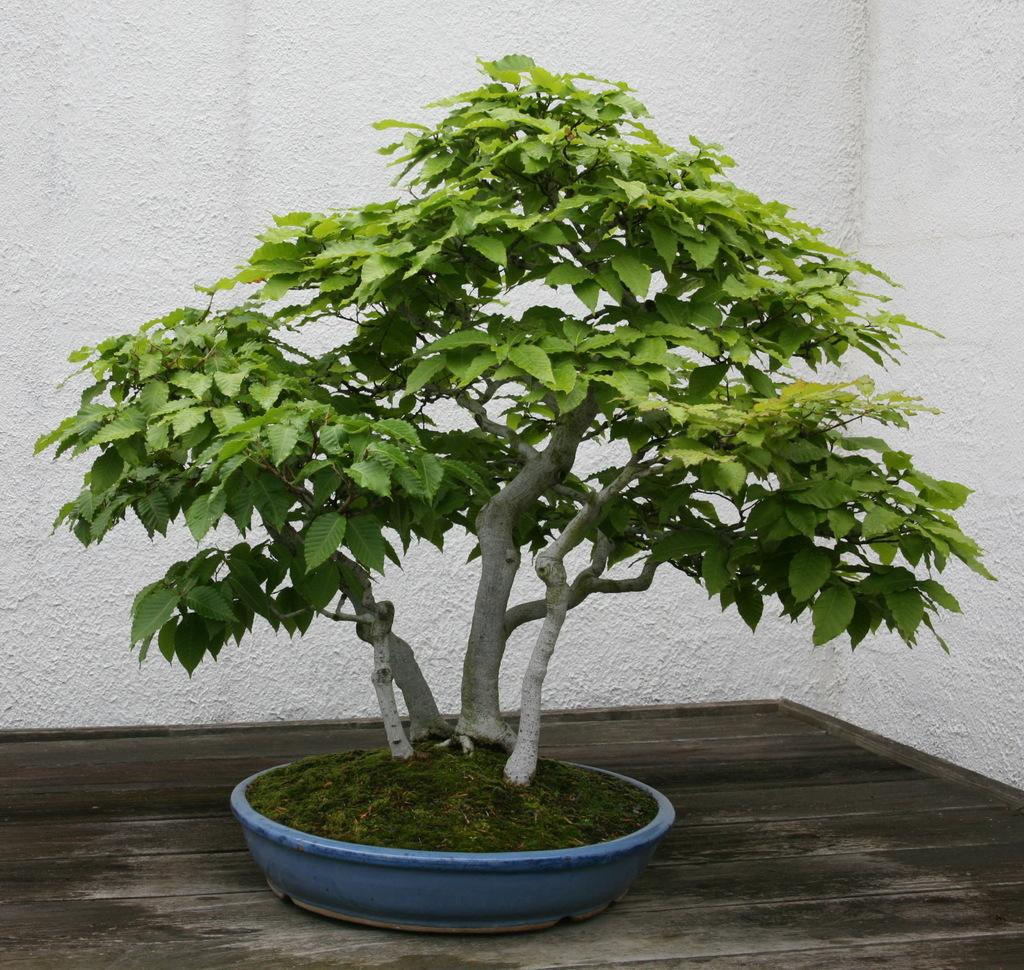What is in the pot that is visible in the image? There is a plant in a pot in the image. Where is the pot placed in the image? The pot is placed on a wooden surface. What can be seen behind the plant in the image? There is a wall visible behind the plant. What type of regret can be seen on the plant's face in the image? There is no face or expression on the plant in the image, as plants do not have emotions or the ability to express regret. 